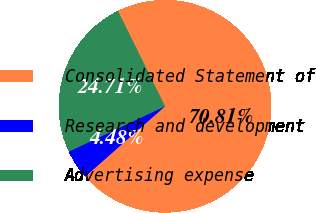Convert chart to OTSL. <chart><loc_0><loc_0><loc_500><loc_500><pie_chart><fcel>Consolidated Statement of<fcel>Research and development<fcel>Advertising expense<nl><fcel>70.81%<fcel>4.48%<fcel>24.71%<nl></chart> 